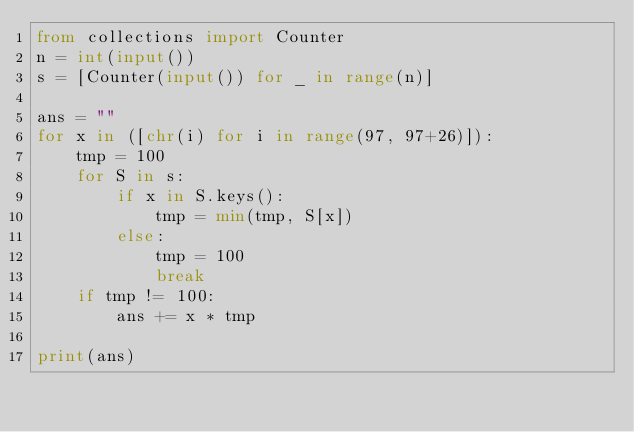<code> <loc_0><loc_0><loc_500><loc_500><_Python_>from collections import Counter
n = int(input())
s = [Counter(input()) for _ in range(n)]

ans = ""
for x in ([chr(i) for i in range(97, 97+26)]):
    tmp = 100
    for S in s:
        if x in S.keys():
            tmp = min(tmp, S[x])
        else:
            tmp = 100
            break
    if tmp != 100:
        ans += x * tmp

print(ans)</code> 